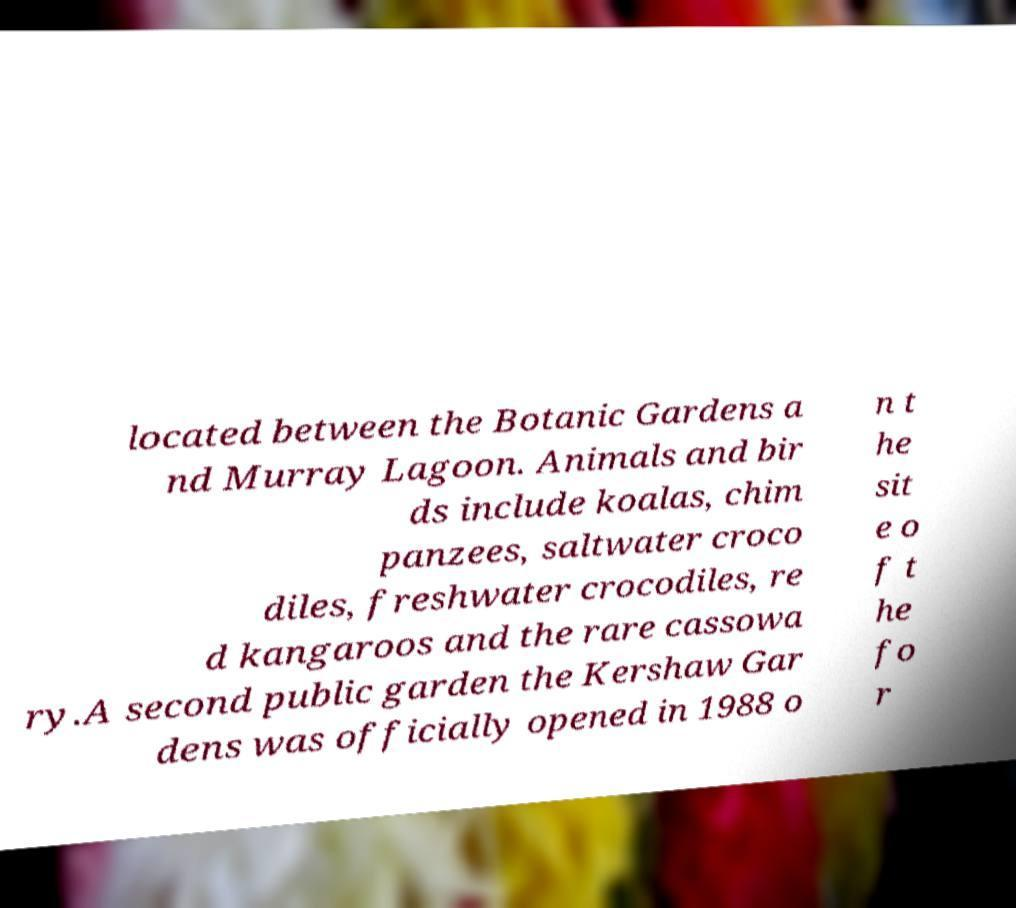There's text embedded in this image that I need extracted. Can you transcribe it verbatim? located between the Botanic Gardens a nd Murray Lagoon. Animals and bir ds include koalas, chim panzees, saltwater croco diles, freshwater crocodiles, re d kangaroos and the rare cassowa ry.A second public garden the Kershaw Gar dens was officially opened in 1988 o n t he sit e o f t he fo r 